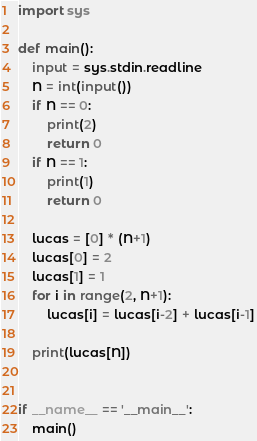Convert code to text. <code><loc_0><loc_0><loc_500><loc_500><_Python_>import sys

def main():
    input = sys.stdin.readline
    N = int(input())
    if N == 0:
        print(2)
        return 0
    if N == 1:
        print(1)
        return 0

    lucas = [0] * (N+1)
    lucas[0] = 2
    lucas[1] = 1
    for i in range(2, N+1):
        lucas[i] = lucas[i-2] + lucas[i-1]

    print(lucas[N])


if __name__ == '__main__':
    main()
</code> 